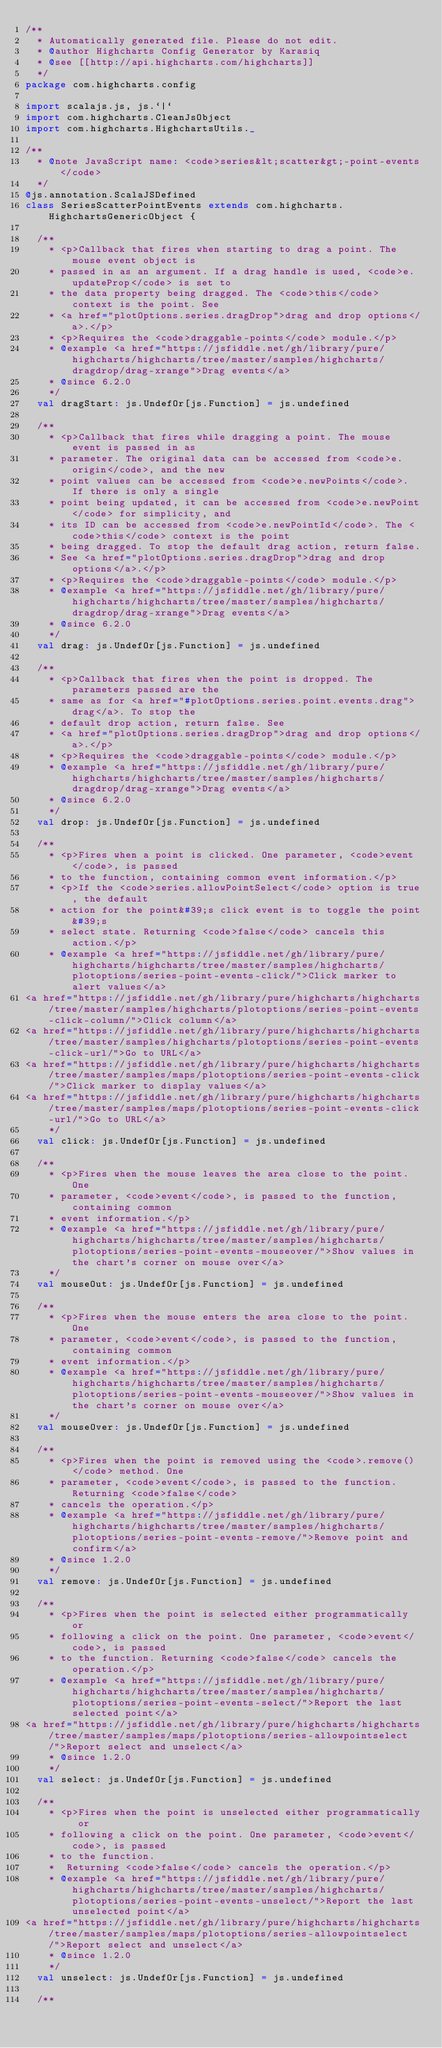Convert code to text. <code><loc_0><loc_0><loc_500><loc_500><_Scala_>/**
  * Automatically generated file. Please do not edit.
  * @author Highcharts Config Generator by Karasiq
  * @see [[http://api.highcharts.com/highcharts]]
  */
package com.highcharts.config

import scalajs.js, js.`|`
import com.highcharts.CleanJsObject
import com.highcharts.HighchartsUtils._

/**
  * @note JavaScript name: <code>series&lt;scatter&gt;-point-events</code>
  */
@js.annotation.ScalaJSDefined
class SeriesScatterPointEvents extends com.highcharts.HighchartsGenericObject {

  /**
    * <p>Callback that fires when starting to drag a point. The mouse event object is
    * passed in as an argument. If a drag handle is used, <code>e.updateProp</code> is set to
    * the data property being dragged. The <code>this</code> context is the point. See
    * <a href="plotOptions.series.dragDrop">drag and drop options</a>.</p>
    * <p>Requires the <code>draggable-points</code> module.</p>
    * @example <a href="https://jsfiddle.net/gh/library/pure/highcharts/highcharts/tree/master/samples/highcharts/dragdrop/drag-xrange">Drag events</a>
    * @since 6.2.0
    */
  val dragStart: js.UndefOr[js.Function] = js.undefined

  /**
    * <p>Callback that fires while dragging a point. The mouse event is passed in as
    * parameter. The original data can be accessed from <code>e.origin</code>, and the new
    * point values can be accessed from <code>e.newPoints</code>. If there is only a single
    * point being updated, it can be accessed from <code>e.newPoint</code> for simplicity, and
    * its ID can be accessed from <code>e.newPointId</code>. The <code>this</code> context is the point
    * being dragged. To stop the default drag action, return false.
    * See <a href="plotOptions.series.dragDrop">drag and drop options</a>.</p>
    * <p>Requires the <code>draggable-points</code> module.</p>
    * @example <a href="https://jsfiddle.net/gh/library/pure/highcharts/highcharts/tree/master/samples/highcharts/dragdrop/drag-xrange">Drag events</a>
    * @since 6.2.0
    */
  val drag: js.UndefOr[js.Function] = js.undefined

  /**
    * <p>Callback that fires when the point is dropped. The parameters passed are the
    * same as for <a href="#plotOptions.series.point.events.drag">drag</a>. To stop the
    * default drop action, return false. See
    * <a href="plotOptions.series.dragDrop">drag and drop options</a>.</p>
    * <p>Requires the <code>draggable-points</code> module.</p>
    * @example <a href="https://jsfiddle.net/gh/library/pure/highcharts/highcharts/tree/master/samples/highcharts/dragdrop/drag-xrange">Drag events</a>
    * @since 6.2.0
    */
  val drop: js.UndefOr[js.Function] = js.undefined

  /**
    * <p>Fires when a point is clicked. One parameter, <code>event</code>, is passed
    * to the function, containing common event information.</p>
    * <p>If the <code>series.allowPointSelect</code> option is true, the default
    * action for the point&#39;s click event is to toggle the point&#39;s
    * select state. Returning <code>false</code> cancels this action.</p>
    * @example <a href="https://jsfiddle.net/gh/library/pure/highcharts/highcharts/tree/master/samples/highcharts/plotoptions/series-point-events-click/">Click marker to alert values</a>
<a href="https://jsfiddle.net/gh/library/pure/highcharts/highcharts/tree/master/samples/highcharts/plotoptions/series-point-events-click-column/">Click column</a>
<a href="https://jsfiddle.net/gh/library/pure/highcharts/highcharts/tree/master/samples/highcharts/plotoptions/series-point-events-click-url/">Go to URL</a>
<a href="https://jsfiddle.net/gh/library/pure/highcharts/highcharts/tree/master/samples/maps/plotoptions/series-point-events-click/">Click marker to display values</a>
<a href="https://jsfiddle.net/gh/library/pure/highcharts/highcharts/tree/master/samples/maps/plotoptions/series-point-events-click-url/">Go to URL</a>
    */
  val click: js.UndefOr[js.Function] = js.undefined

  /**
    * <p>Fires when the mouse leaves the area close to the point. One
    * parameter, <code>event</code>, is passed to the function, containing common
    * event information.</p>
    * @example <a href="https://jsfiddle.net/gh/library/pure/highcharts/highcharts/tree/master/samples/highcharts/plotoptions/series-point-events-mouseover/">Show values in the chart's corner on mouse over</a>
    */
  val mouseOut: js.UndefOr[js.Function] = js.undefined

  /**
    * <p>Fires when the mouse enters the area close to the point. One
    * parameter, <code>event</code>, is passed to the function, containing common
    * event information.</p>
    * @example <a href="https://jsfiddle.net/gh/library/pure/highcharts/highcharts/tree/master/samples/highcharts/plotoptions/series-point-events-mouseover/">Show values in the chart's corner on mouse over</a>
    */
  val mouseOver: js.UndefOr[js.Function] = js.undefined

  /**
    * <p>Fires when the point is removed using the <code>.remove()</code> method. One
    * parameter, <code>event</code>, is passed to the function. Returning <code>false</code>
    * cancels the operation.</p>
    * @example <a href="https://jsfiddle.net/gh/library/pure/highcharts/highcharts/tree/master/samples/highcharts/plotoptions/series-point-events-remove/">Remove point and confirm</a>
    * @since 1.2.0
    */
  val remove: js.UndefOr[js.Function] = js.undefined

  /**
    * <p>Fires when the point is selected either programmatically or
    * following a click on the point. One parameter, <code>event</code>, is passed
    * to the function. Returning <code>false</code> cancels the operation.</p>
    * @example <a href="https://jsfiddle.net/gh/library/pure/highcharts/highcharts/tree/master/samples/highcharts/plotoptions/series-point-events-select/">Report the last selected point</a>
<a href="https://jsfiddle.net/gh/library/pure/highcharts/highcharts/tree/master/samples/maps/plotoptions/series-allowpointselect/">Report select and unselect</a>
    * @since 1.2.0
    */
  val select: js.UndefOr[js.Function] = js.undefined

  /**
    * <p>Fires when the point is unselected either programmatically or
    * following a click on the point. One parameter, <code>event</code>, is passed
    * to the function.
    *  Returning <code>false</code> cancels the operation.</p>
    * @example <a href="https://jsfiddle.net/gh/library/pure/highcharts/highcharts/tree/master/samples/highcharts/plotoptions/series-point-events-unselect/">Report the last unselected point</a>
<a href="https://jsfiddle.net/gh/library/pure/highcharts/highcharts/tree/master/samples/maps/plotoptions/series-allowpointselect/">Report select and unselect</a>
    * @since 1.2.0
    */
  val unselect: js.UndefOr[js.Function] = js.undefined

  /**</code> 